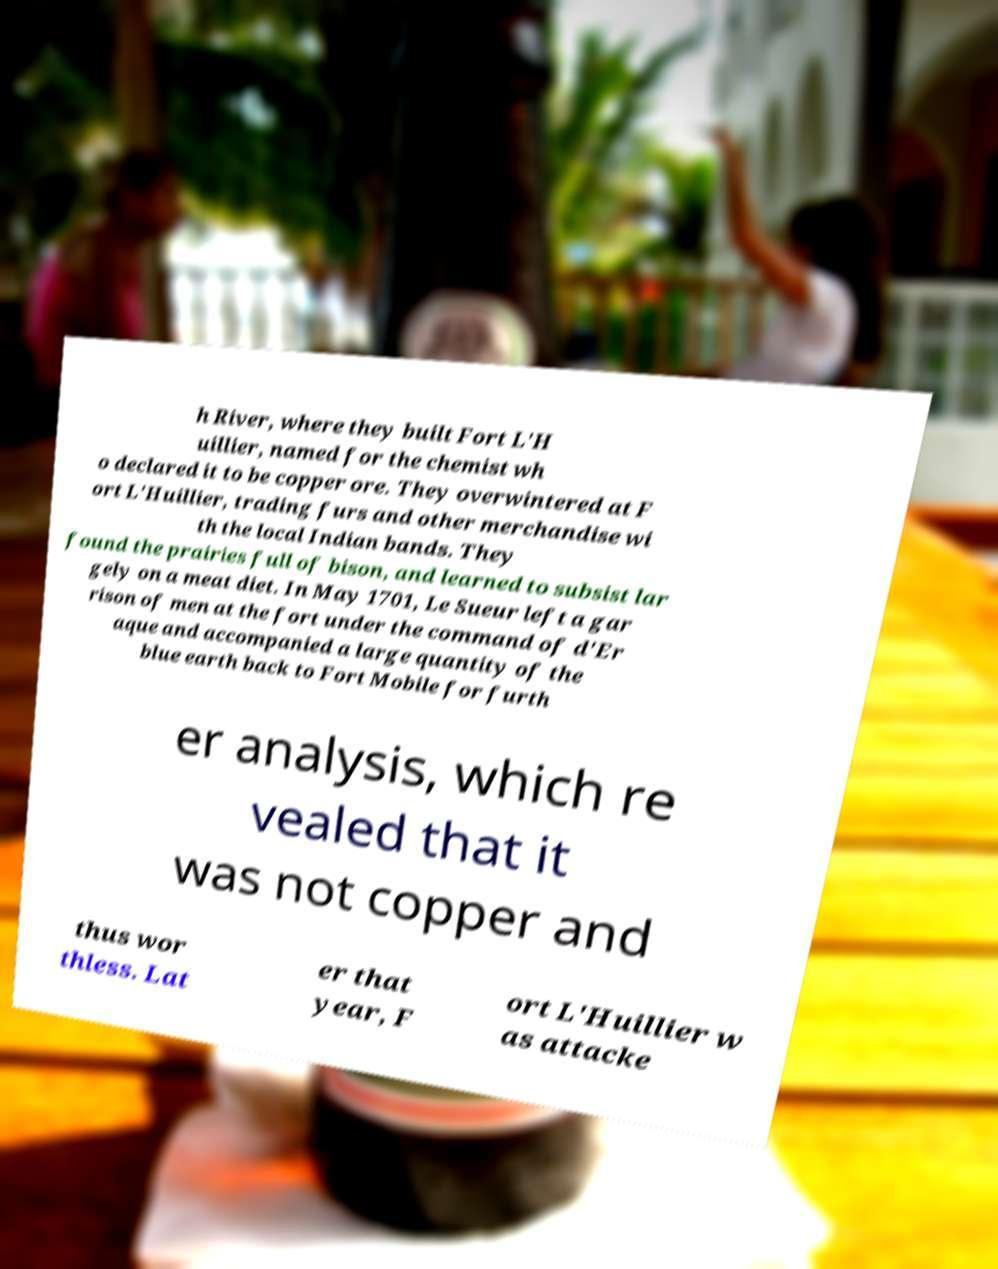What messages or text are displayed in this image? I need them in a readable, typed format. h River, where they built Fort L'H uillier, named for the chemist wh o declared it to be copper ore. They overwintered at F ort L'Huillier, trading furs and other merchandise wi th the local Indian bands. They found the prairies full of bison, and learned to subsist lar gely on a meat diet. In May 1701, Le Sueur left a gar rison of men at the fort under the command of d'Er aque and accompanied a large quantity of the blue earth back to Fort Mobile for furth er analysis, which re vealed that it was not copper and thus wor thless. Lat er that year, F ort L'Huillier w as attacke 